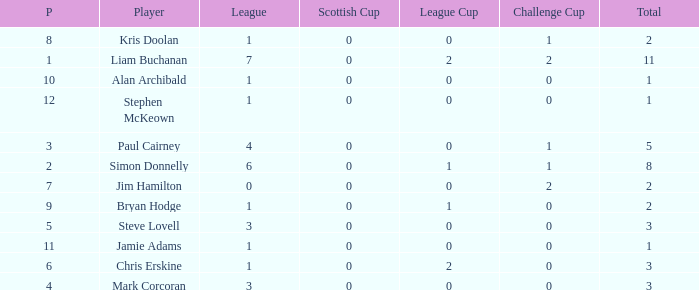How many points did player 7 score in the challenge cup? 1.0. Write the full table. {'header': ['P', 'Player', 'League', 'Scottish Cup', 'League Cup', 'Challenge Cup', 'Total'], 'rows': [['8', 'Kris Doolan', '1', '0', '0', '1', '2'], ['1', 'Liam Buchanan', '7', '0', '2', '2', '11'], ['10', 'Alan Archibald', '1', '0', '0', '0', '1'], ['12', 'Stephen McKeown', '1', '0', '0', '0', '1'], ['3', 'Paul Cairney', '4', '0', '0', '1', '5'], ['2', 'Simon Donnelly', '6', '0', '1', '1', '8'], ['7', 'Jim Hamilton', '0', '0', '0', '2', '2'], ['9', 'Bryan Hodge', '1', '0', '1', '0', '2'], ['5', 'Steve Lovell', '3', '0', '0', '0', '3'], ['11', 'Jamie Adams', '1', '0', '0', '0', '1'], ['6', 'Chris Erskine', '1', '0', '2', '0', '3'], ['4', 'Mark Corcoran', '3', '0', '0', '0', '3']]} 